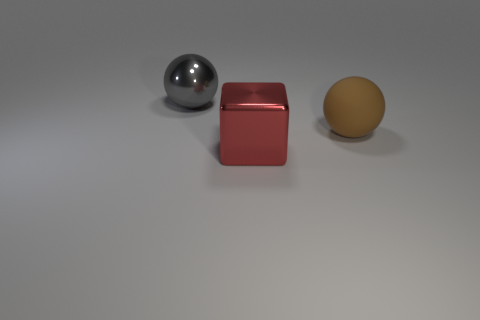Add 1 large objects. How many objects exist? 4 Subtract all brown spheres. How many spheres are left? 1 Subtract all cubes. How many objects are left? 2 Subtract 2 spheres. How many spheres are left? 0 Subtract 0 green cubes. How many objects are left? 3 Subtract all yellow spheres. Subtract all cyan cubes. How many spheres are left? 2 Subtract all blue cylinders. How many purple cubes are left? 0 Subtract all cyan metal spheres. Subtract all big red metal blocks. How many objects are left? 2 Add 2 red shiny things. How many red shiny things are left? 3 Add 2 tiny blue metal blocks. How many tiny blue metal blocks exist? 2 